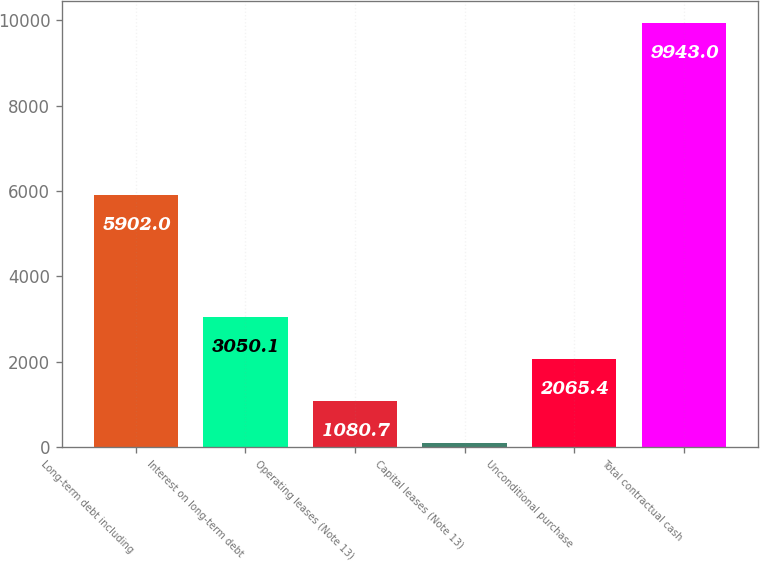Convert chart. <chart><loc_0><loc_0><loc_500><loc_500><bar_chart><fcel>Long-term debt including<fcel>Interest on long-term debt<fcel>Operating leases (Note 13)<fcel>Capital leases (Note 13)<fcel>Unconditional purchase<fcel>Total contractual cash<nl><fcel>5902<fcel>3050.1<fcel>1080.7<fcel>96<fcel>2065.4<fcel>9943<nl></chart> 